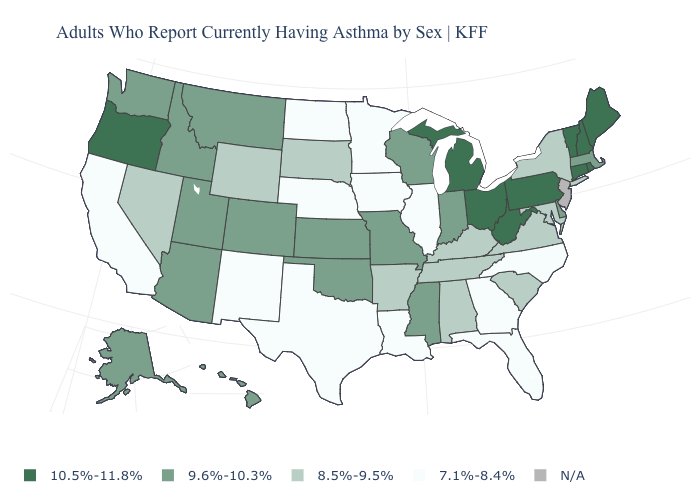Is the legend a continuous bar?
Short answer required. No. What is the value of Alabama?
Write a very short answer. 8.5%-9.5%. Name the states that have a value in the range N/A?
Write a very short answer. New Jersey. How many symbols are there in the legend?
Be succinct. 5. What is the value of Kentucky?
Answer briefly. 8.5%-9.5%. Among the states that border Massachusetts , does New York have the lowest value?
Quick response, please. Yes. Which states have the highest value in the USA?
Keep it brief. Connecticut, Maine, Michigan, New Hampshire, Ohio, Oregon, Pennsylvania, Rhode Island, Vermont, West Virginia. Name the states that have a value in the range 7.1%-8.4%?
Answer briefly. California, Florida, Georgia, Illinois, Iowa, Louisiana, Minnesota, Nebraska, New Mexico, North Carolina, North Dakota, Texas. What is the value of Kansas?
Concise answer only. 9.6%-10.3%. Does the first symbol in the legend represent the smallest category?
Give a very brief answer. No. Name the states that have a value in the range 10.5%-11.8%?
Be succinct. Connecticut, Maine, Michigan, New Hampshire, Ohio, Oregon, Pennsylvania, Rhode Island, Vermont, West Virginia. What is the value of Washington?
Concise answer only. 9.6%-10.3%. What is the lowest value in the USA?
Be succinct. 7.1%-8.4%. What is the value of Illinois?
Be succinct. 7.1%-8.4%. 